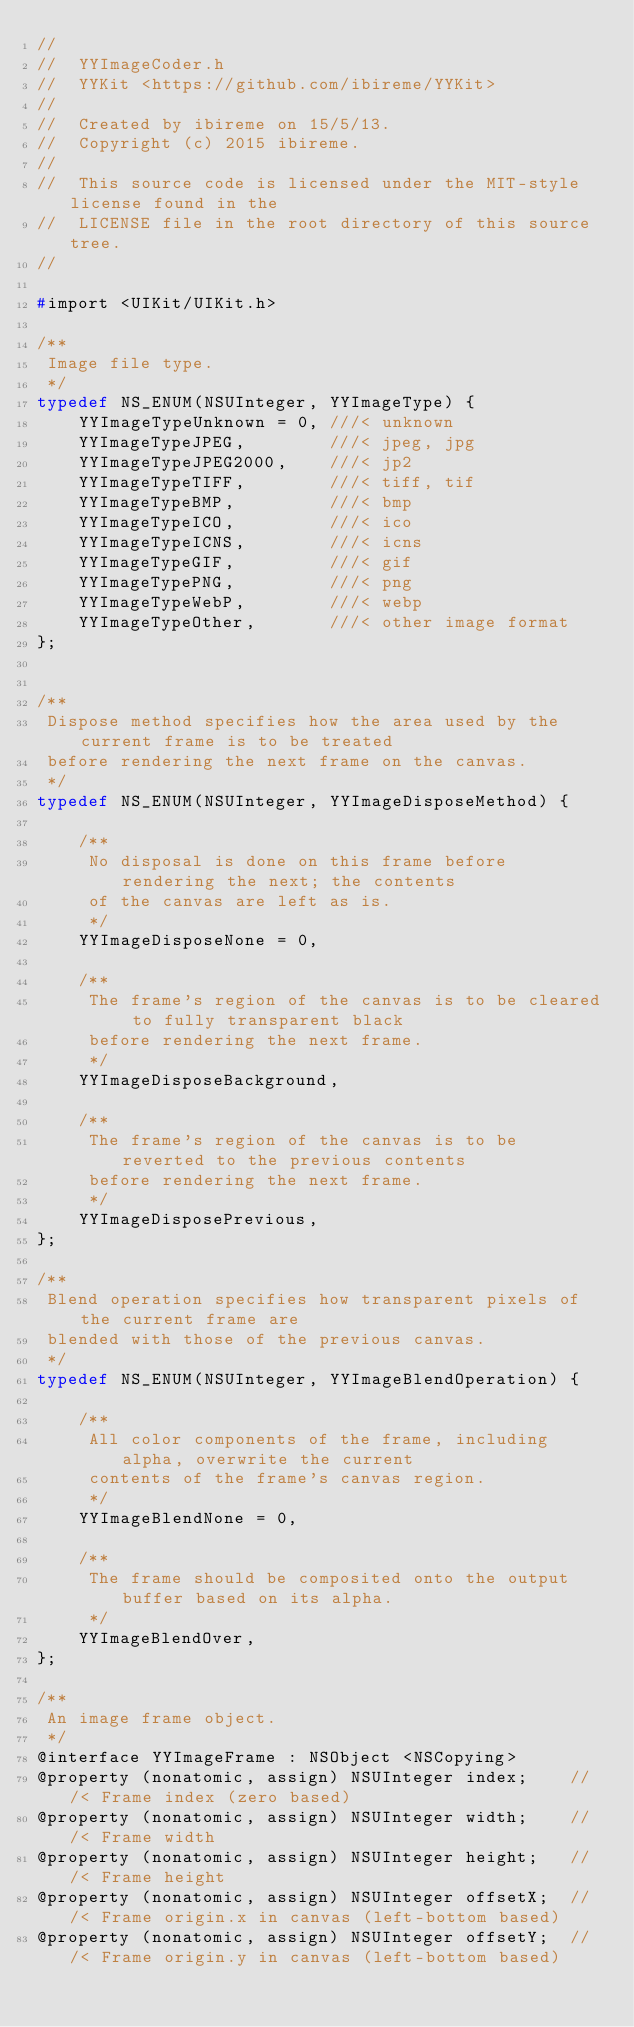<code> <loc_0><loc_0><loc_500><loc_500><_C_>//
//  YYImageCoder.h
//  YYKit <https://github.com/ibireme/YYKit>
//
//  Created by ibireme on 15/5/13.
//  Copyright (c) 2015 ibireme.
//
//  This source code is licensed under the MIT-style license found in the
//  LICENSE file in the root directory of this source tree.
//

#import <UIKit/UIKit.h>

/**
 Image file type.
 */
typedef NS_ENUM(NSUInteger, YYImageType) {
    YYImageTypeUnknown = 0, ///< unknown
    YYImageTypeJPEG,        ///< jpeg, jpg
    YYImageTypeJPEG2000,    ///< jp2
    YYImageTypeTIFF,        ///< tiff, tif
    YYImageTypeBMP,         ///< bmp
    YYImageTypeICO,         ///< ico
    YYImageTypeICNS,        ///< icns
    YYImageTypeGIF,         ///< gif
    YYImageTypePNG,         ///< png
    YYImageTypeWebP,        ///< webp
    YYImageTypeOther,       ///< other image format
};


/**
 Dispose method specifies how the area used by the current frame is to be treated
 before rendering the next frame on the canvas.
 */
typedef NS_ENUM(NSUInteger, YYImageDisposeMethod) {
    
    /**
     No disposal is done on this frame before rendering the next; the contents
     of the canvas are left as is.
     */
    YYImageDisposeNone = 0,
    
    /**
     The frame's region of the canvas is to be cleared to fully transparent black
     before rendering the next frame.
     */
    YYImageDisposeBackground,
    
    /**
     The frame's region of the canvas is to be reverted to the previous contents
     before rendering the next frame.
     */
    YYImageDisposePrevious,
};

/**
 Blend operation specifies how transparent pixels of the current frame are
 blended with those of the previous canvas.
 */
typedef NS_ENUM(NSUInteger, YYImageBlendOperation) {
    
    /**
     All color components of the frame, including alpha, overwrite the current
     contents of the frame's canvas region.
     */
    YYImageBlendNone = 0,
    
    /**
     The frame should be composited onto the output buffer based on its alpha.
     */
    YYImageBlendOver,
};

/**
 An image frame object.
 */
@interface YYImageFrame : NSObject <NSCopying>
@property (nonatomic, assign) NSUInteger index;    ///< Frame index (zero based)
@property (nonatomic, assign) NSUInteger width;    ///< Frame width
@property (nonatomic, assign) NSUInteger height;   ///< Frame height
@property (nonatomic, assign) NSUInteger offsetX;  ///< Frame origin.x in canvas (left-bottom based)
@property (nonatomic, assign) NSUInteger offsetY;  ///< Frame origin.y in canvas (left-bottom based)</code> 